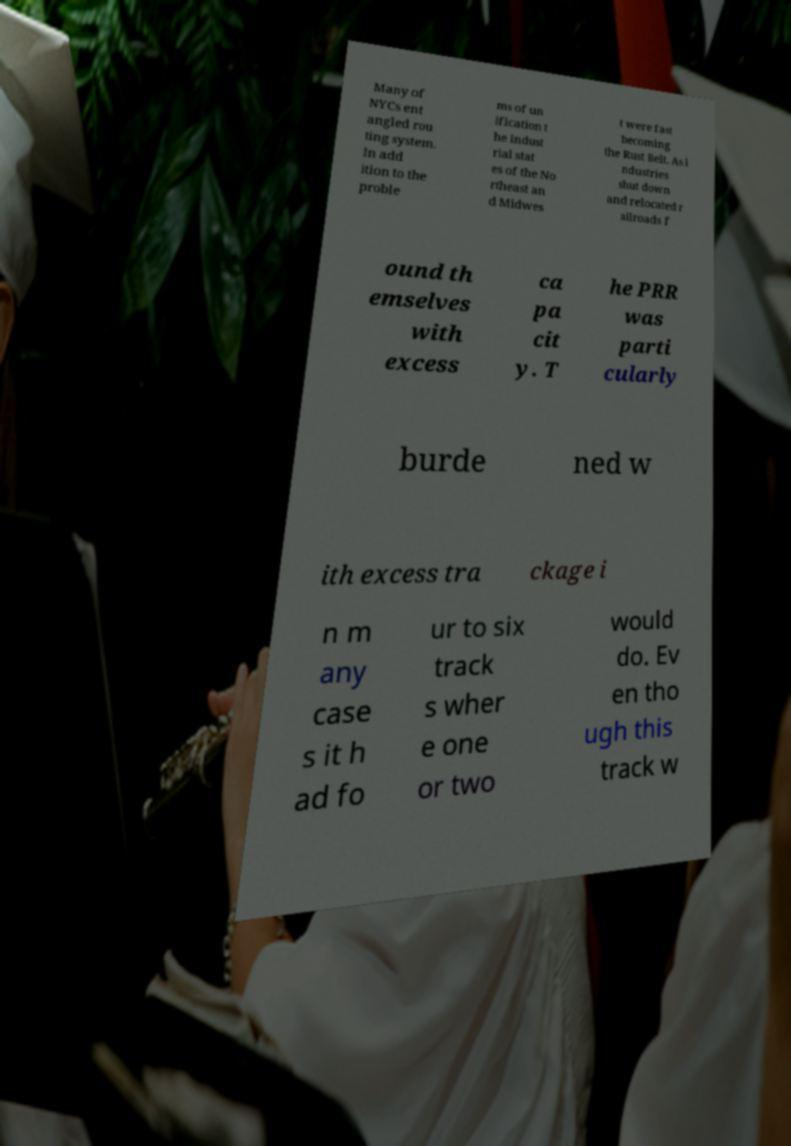Could you extract and type out the text from this image? Many of NYCs ent angled rou ting system. In add ition to the proble ms of un ification t he indust rial stat es of the No rtheast an d Midwes t were fast becoming the Rust Belt. As i ndustries shut down and relocated r ailroads f ound th emselves with excess ca pa cit y. T he PRR was parti cularly burde ned w ith excess tra ckage i n m any case s it h ad fo ur to six track s wher e one or two would do. Ev en tho ugh this track w 